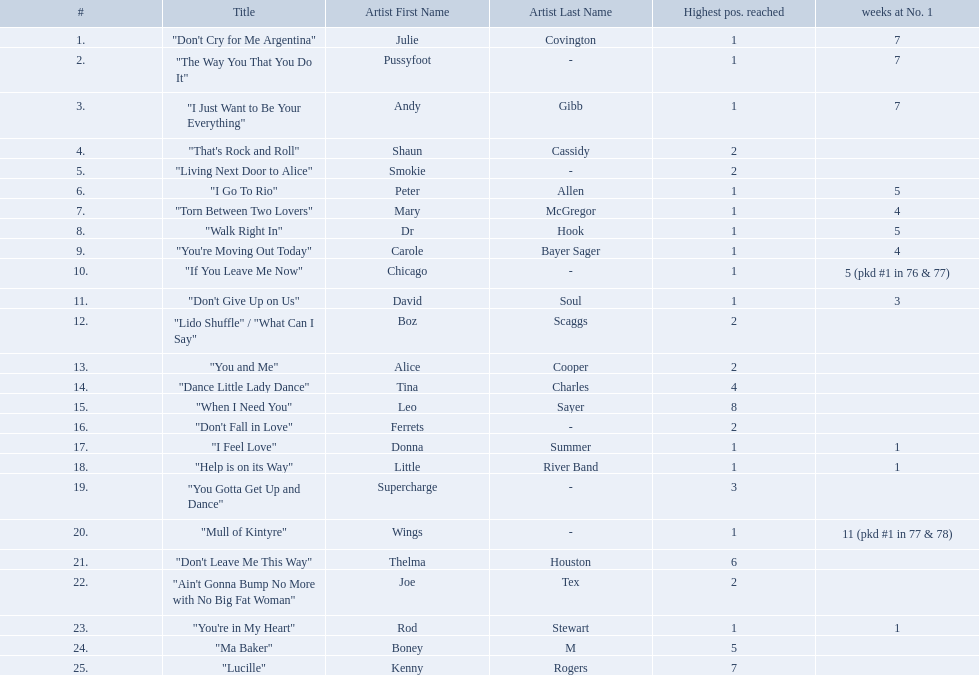Who had the one of the least weeks at number one? Rod Stewart. Who had no week at number one? Shaun Cassidy. Who had the highest number of weeks at number one? Wings. 